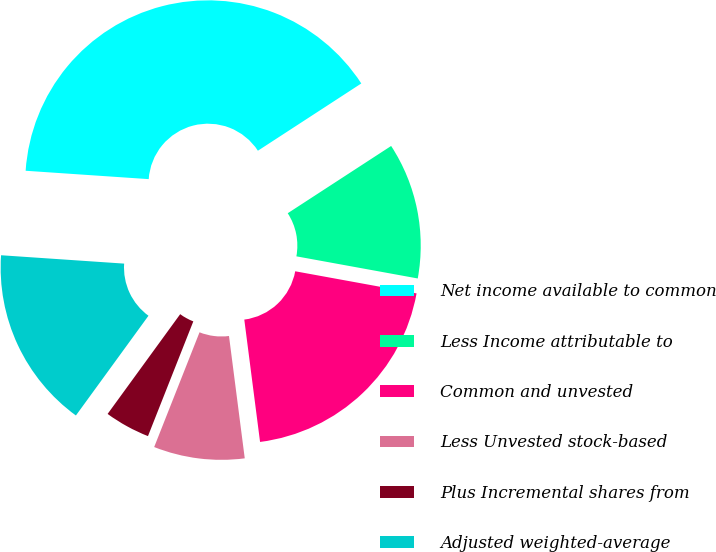Convert chart to OTSL. <chart><loc_0><loc_0><loc_500><loc_500><pie_chart><fcel>Net income available to common<fcel>Less Income attributable to<fcel>Common and unvested<fcel>Less Unvested stock-based<fcel>Plus Incremental shares from<fcel>Adjusted weighted-average<fcel>Diluted earnings per common<nl><fcel>39.74%<fcel>12.05%<fcel>20.09%<fcel>8.03%<fcel>4.02%<fcel>16.07%<fcel>0.0%<nl></chart> 